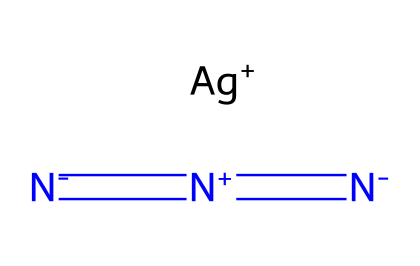What is the molecular formula of silver azide? The chemical consists of one silver (Ag) atom and three nitrogen (N) atoms. Thus, the molecular formula is AgN3.
Answer: AgN3 How many nitrogen atoms are present in silver azide? Upon examining the structure, it shows a total of three nitrogen atoms linked by double bonds.
Answer: three What type of bonding is indicated between the nitrogen atoms in silver azide? The structure shows double bonds between the nitrogen atoms, indicating that they are covalently bonded to each other.
Answer: double bond What is the oxidation state of silver in silver azide? In this compound, silver is represented as Ag+, indicating an oxidation state of +1.
Answer: +1 Is silver azide a stable compound? The structure suggests that silver azide is a light-sensitive compound and is known to be unstable under certain conditions.
Answer: no What characteristic of silver azide makes it useful in photography? The light sensitivity of silver azide is due to its ability to decompose upon exposure to light, which is useful for capturing images.
Answer: light-sensitive What chemical classification does silver azide belong to? Given its structure with the nitrogen group, silver azide is classified as an azide.
Answer: azide 